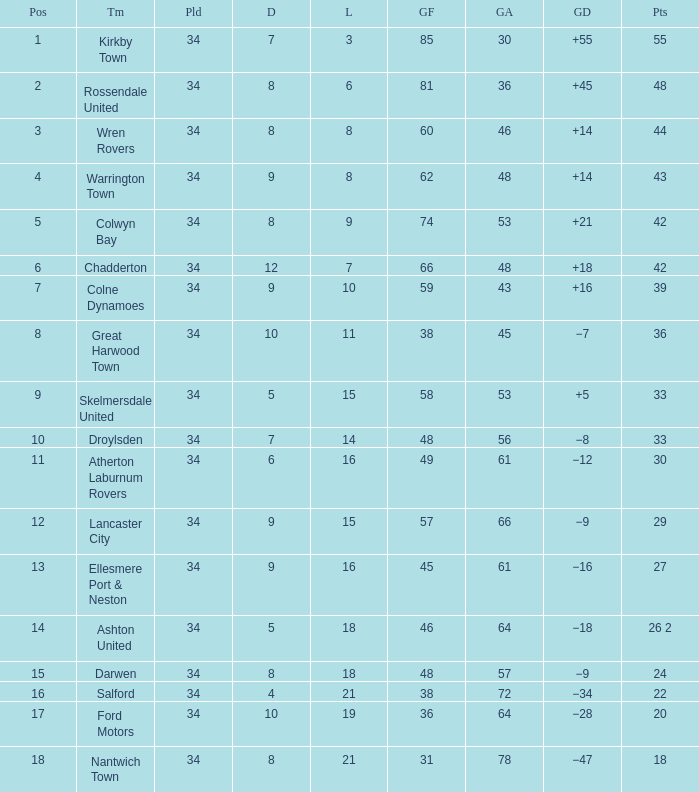Could you help me parse every detail presented in this table? {'header': ['Pos', 'Tm', 'Pld', 'D', 'L', 'GF', 'GA', 'GD', 'Pts'], 'rows': [['1', 'Kirkby Town', '34', '7', '3', '85', '30', '+55', '55'], ['2', 'Rossendale United', '34', '8', '6', '81', '36', '+45', '48'], ['3', 'Wren Rovers', '34', '8', '8', '60', '46', '+14', '44'], ['4', 'Warrington Town', '34', '9', '8', '62', '48', '+14', '43'], ['5', 'Colwyn Bay', '34', '8', '9', '74', '53', '+21', '42'], ['6', 'Chadderton', '34', '12', '7', '66', '48', '+18', '42'], ['7', 'Colne Dynamoes', '34', '9', '10', '59', '43', '+16', '39'], ['8', 'Great Harwood Town', '34', '10', '11', '38', '45', '−7', '36'], ['9', 'Skelmersdale United', '34', '5', '15', '58', '53', '+5', '33'], ['10', 'Droylsden', '34', '7', '14', '48', '56', '−8', '33'], ['11', 'Atherton Laburnum Rovers', '34', '6', '16', '49', '61', '−12', '30'], ['12', 'Lancaster City', '34', '9', '15', '57', '66', '−9', '29'], ['13', 'Ellesmere Port & Neston', '34', '9', '16', '45', '61', '−16', '27'], ['14', 'Ashton United', '34', '5', '18', '46', '64', '−18', '26 2'], ['15', 'Darwen', '34', '8', '18', '48', '57', '−9', '24'], ['16', 'Salford', '34', '4', '21', '38', '72', '−34', '22'], ['17', 'Ford Motors', '34', '10', '19', '36', '64', '−28', '20'], ['18', 'Nantwich Town', '34', '8', '21', '31', '78', '−47', '18']]} What is the smallest number of goals against when 8 games were lost, and the goals for are 60? 46.0. 